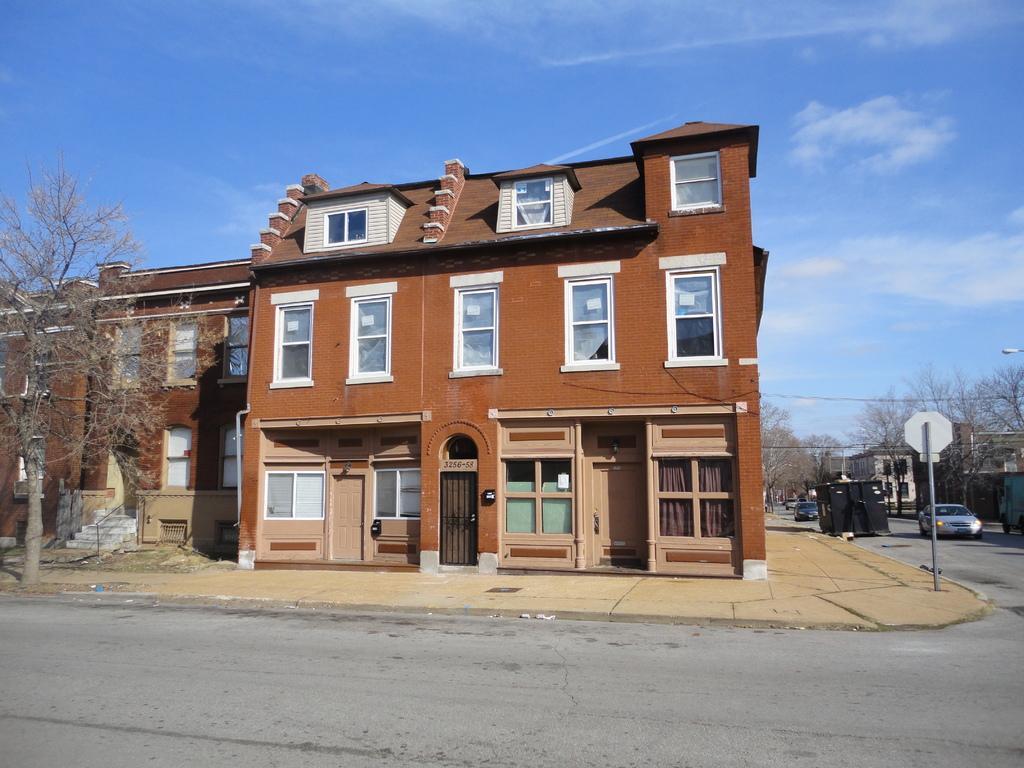Please provide a concise description of this image. As we can see in the image there are buildings, trees, windows, doors, stairs, cars, sky and clouds. 